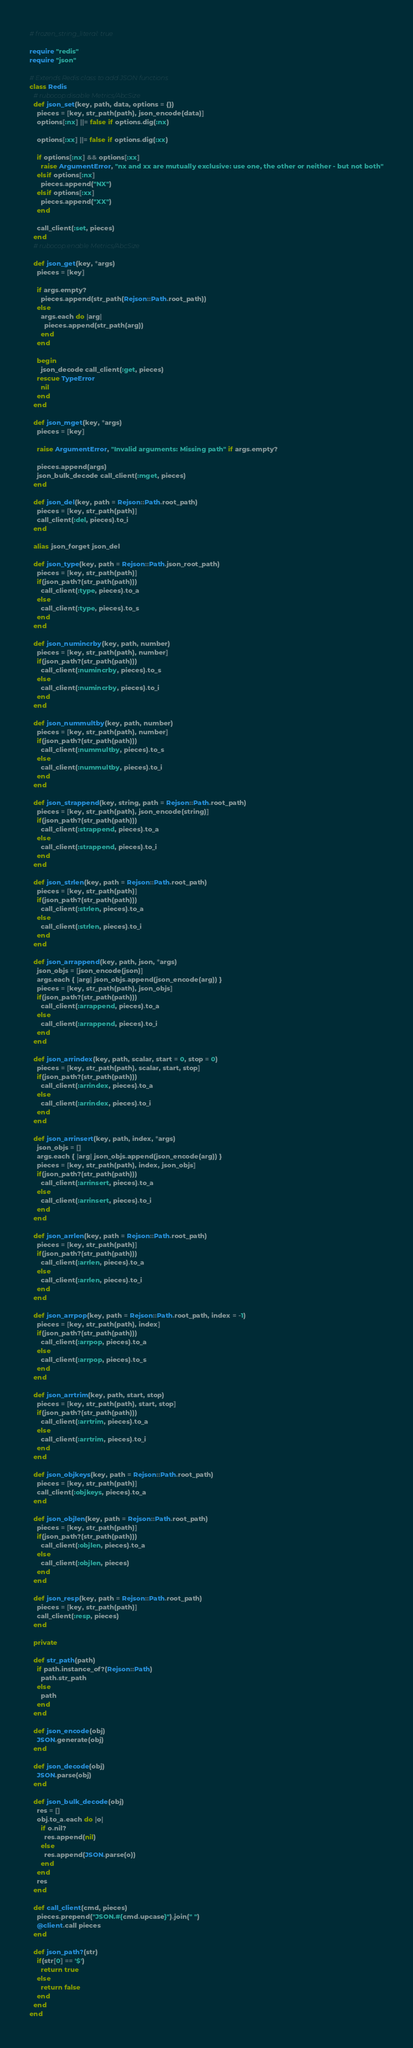<code> <loc_0><loc_0><loc_500><loc_500><_Ruby_># frozen_string_literal: true

require "redis"
require "json"

# Extends Redis class to add JSON functions
class Redis
  # rubocop:disable Metrics/AbcSize
  def json_set(key, path, data, options = {})
    pieces = [key, str_path(path), json_encode(data)]
    options[:nx] ||= false if options.dig(:nx)

    options[:xx] ||= false if options.dig(:xx)

    if options[:nx] && options[:xx]
      raise ArgumentError, "nx and xx are mutually exclusive: use one, the other or neither - but not both"
    elsif options[:nx]
      pieces.append("NX")
    elsif options[:xx]
      pieces.append("XX")
    end

    call_client(:set, pieces)
  end
  # rubocop:enable Metrics/AbcSize

  def json_get(key, *args)
    pieces = [key]

    if args.empty?
      pieces.append(str_path(Rejson::Path.root_path))
    else
      args.each do |arg|
        pieces.append(str_path(arg))
      end
    end

    begin
      json_decode call_client(:get, pieces)
    rescue TypeError
      nil
    end
  end

  def json_mget(key, *args)
    pieces = [key]

    raise ArgumentError, "Invalid arguments: Missing path" if args.empty?

    pieces.append(args)
    json_bulk_decode call_client(:mget, pieces)
  end

  def json_del(key, path = Rejson::Path.root_path)
    pieces = [key, str_path(path)]
    call_client(:del, pieces).to_i
  end

  alias json_forget json_del

  def json_type(key, path = Rejson::Path.json_root_path)
    pieces = [key, str_path(path)]
    if(json_path?(str_path(path)))
      call_client(:type, pieces).to_a
    else
      call_client(:type, pieces).to_s
    end
  end

  def json_numincrby(key, path, number)
    pieces = [key, str_path(path), number]
    if(json_path?(str_path(path)))
      call_client(:numincrby, pieces).to_s
    else
      call_client(:numincrby, pieces).to_i
    end
  end

  def json_nummultby(key, path, number)
    pieces = [key, str_path(path), number]
    if(json_path?(str_path(path)))
      call_client(:nummultby, pieces).to_s
    else
      call_client(:nummultby, pieces).to_i
    end
  end

  def json_strappend(key, string, path = Rejson::Path.root_path)
    pieces = [key, str_path(path), json_encode(string)]
    if(json_path?(str_path(path)))
      call_client(:strappend, pieces).to_a
    else
      call_client(:strappend, pieces).to_i
    end
  end

  def json_strlen(key, path = Rejson::Path.root_path)
    pieces = [key, str_path(path)]
    if(json_path?(str_path(path)))
      call_client(:strlen, pieces).to_a
    else
      call_client(:strlen, pieces).to_i
    end
  end

  def json_arrappend(key, path, json, *args)
    json_objs = [json_encode(json)]
    args.each { |arg| json_objs.append(json_encode(arg)) }
    pieces = [key, str_path(path), json_objs]
    if(json_path?(str_path(path)))
      call_client(:arrappend, pieces).to_a
    else
      call_client(:arrappend, pieces).to_i
    end
  end

  def json_arrindex(key, path, scalar, start = 0, stop = 0)
    pieces = [key, str_path(path), scalar, start, stop]
    if(json_path?(str_path(path)))
      call_client(:arrindex, pieces).to_a
    else
      call_client(:arrindex, pieces).to_i
    end
  end

  def json_arrinsert(key, path, index, *args)
    json_objs = []
    args.each { |arg| json_objs.append(json_encode(arg)) }
    pieces = [key, str_path(path), index, json_objs]
    if(json_path?(str_path(path)))
      call_client(:arrinsert, pieces).to_a
    else
      call_client(:arrinsert, pieces).to_i
    end
  end

  def json_arrlen(key, path = Rejson::Path.root_path)
    pieces = [key, str_path(path)]
    if(json_path?(str_path(path)))
      call_client(:arrlen, pieces).to_a
    else
      call_client(:arrlen, pieces).to_i
    end
  end

  def json_arrpop(key, path = Rejson::Path.root_path, index = -1)
    pieces = [key, str_path(path), index]
    if(json_path?(str_path(path)))
      call_client(:arrpop, pieces).to_a
    else
      call_client(:arrpop, pieces).to_s
    end
  end

  def json_arrtrim(key, path, start, stop)
    pieces = [key, str_path(path), start, stop]
    if(json_path?(str_path(path)))
      call_client(:arrtrim, pieces).to_a
    else
      call_client(:arrtrim, pieces).to_i
    end
  end

  def json_objkeys(key, path = Rejson::Path.root_path)
    pieces = [key, str_path(path)]
    call_client(:objkeys, pieces).to_a
  end

  def json_objlen(key, path = Rejson::Path.root_path)
    pieces = [key, str_path(path)]
    if(json_path?(str_path(path)))
      call_client(:objlen, pieces).to_a
    else  
      call_client(:objlen, pieces)
    end
  end

  def json_resp(key, path = Rejson::Path.root_path)
    pieces = [key, str_path(path)]
    call_client(:resp, pieces)
  end

  private

  def str_path(path)
    if path.instance_of?(Rejson::Path)
      path.str_path
    else
      path
    end
  end

  def json_encode(obj)
    JSON.generate(obj)
  end

  def json_decode(obj)
    JSON.parse(obj)
  end

  def json_bulk_decode(obj)
    res = []
    obj.to_a.each do |o|
      if o.nil?
        res.append(nil)
      else
        res.append(JSON.parse(o))
      end
    end
    res
  end

  def call_client(cmd, pieces)
    pieces.prepend("JSON.#{cmd.upcase}").join(" ")
    @client.call pieces
  end

  def json_path?(str)
    if(str[0] == '$')
      return true
    else
      return false
    end
  end
end
</code> 